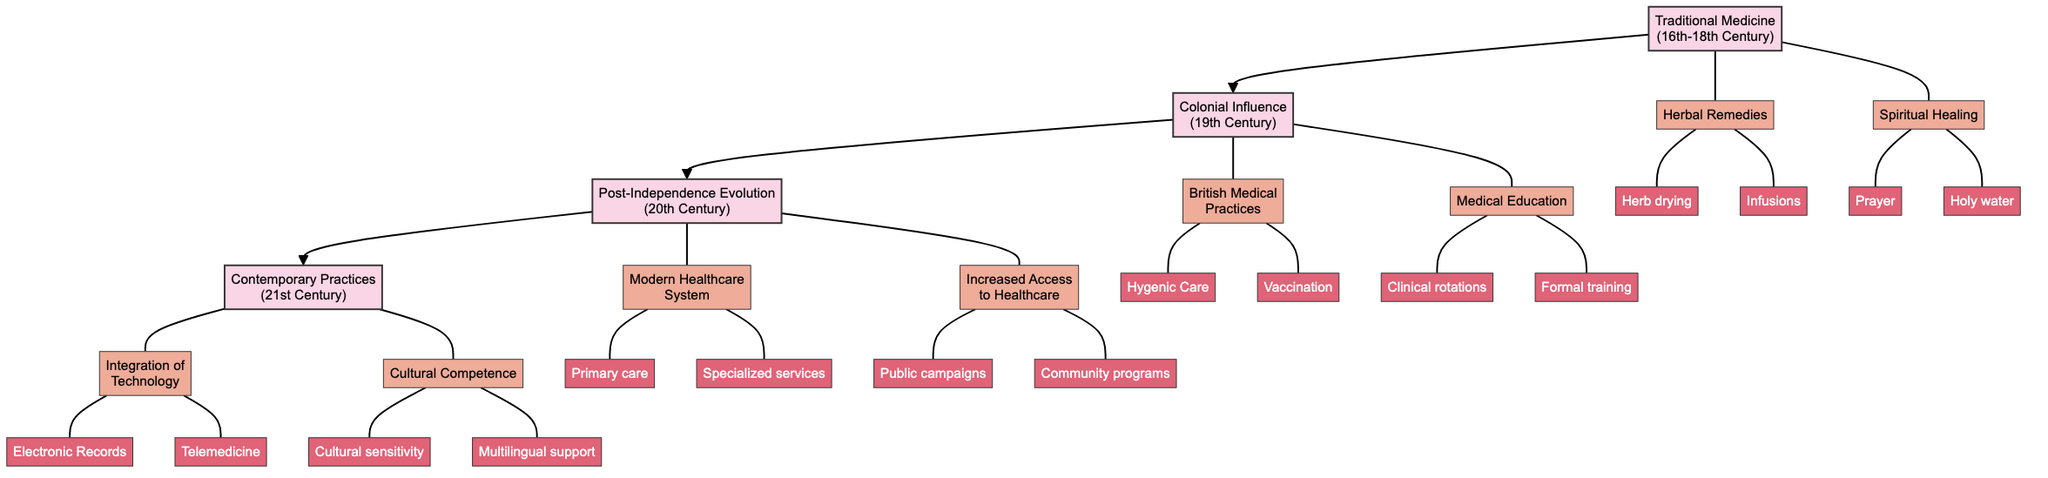What time period does "Traditional Medicine" cover? The diagram indicates that "Traditional Medicine" corresponds to the 16th-18th Century, which is explicitly mentioned in that phase's description.
Answer: 16th-18th Century How many key elements are there in the "Post-Independence Evolution" phase? In the diagram, the "Post-Independence Evolution" phase has two key elements listed: "Modern Healthcare System" and "Increased Access to Healthcare." Therefore, the total count is two.
Answer: 2 What practices are associated with "Herbal Remedies"? The diagram lists two specific practices under "Herbal Remedies": "Herb drying and preparation" and "Infusions and poultices." These are the direct practices mentioned, confirming the answer.
Answer: Herb drying and preparation, Infusions and poultices Which institution is associated with "Introduction of Medical Education"? The diagram specifies that the "University of Malta - Faculty of Medicine" is the institution linked to "Introduction of Medical Education," providing a clear answer derived from the diagram structure.
Answer: University of Malta - Faculty of Medicine What is a practice included under "Cultural Competence"? The diagram lists "Cultural sensitivity training" and "Multilingual support services" as practices related to "Cultural Competence." Therefore, either of these answers would be correct.
Answer: Cultural sensitivity training What phase comes after "Colonial Influence"? The diagram shows a direct sequential flow from "Colonial Influence" to "Post-Independence Evolution," indicating the order of phases clearly.
Answer: Post-Independence Evolution How many total phases are presented in the diagram? The diagram lists four distinct phases: "Traditional Medicine," "Colonial Influence," "Post-Independence Evolution," and "Contemporary Practices." By counting these, we confirm the total is four phases.
Answer: 4 Which key element focuses on advanced medical technologies? The diagram explicitly states that "Integration of Technology" is the key element that pertains to advanced medical technologies within the "Contemporary Practices" phase.
Answer: Integration of Technology 